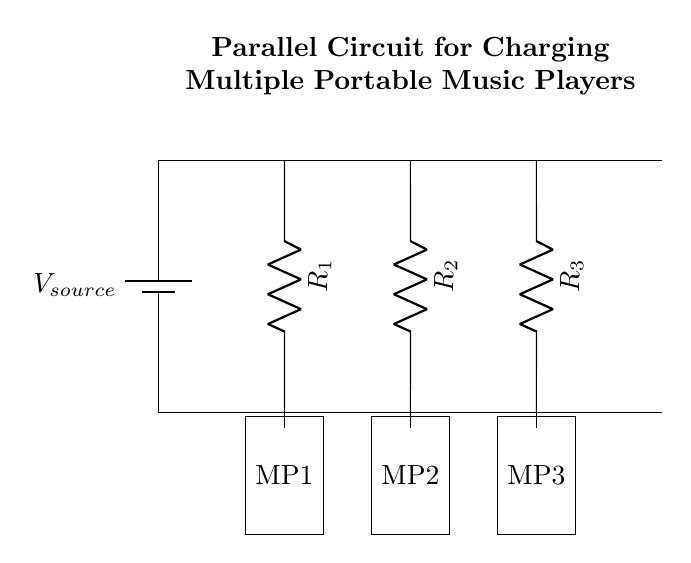What is the type of circuit shown? The circuit is a parallel circuit, as indicated by the arrangement of components where each resistor is connected to the same two nodes, allowing multiple paths for current to flow.
Answer: Parallel circuit How many music players are in the circuit? There are three music players shown in the circuit diagram, designated as MP1, MP2, and MP3, each connected to its own resistor.
Answer: Three What is the primary function of this circuit? This circuit is designed to charge multiple portable music players simultaneously, allowing each player to receive current independently.
Answer: Charge music players What would happen if one of the resistors failed? If one resistor fails, the remaining resistors would still allow current to flow, and the other music players would continue to charge, highlighting the reliability of parallel circuits.
Answer: Others continue charging What is the role of the voltage source in this circuit? The voltage source provides the necessary electrical potential to drive the current through the circuit, allowing energy to be delivered to all connected players.
Answer: Provides voltage What is the effect of adding more music players to the circuit? Adding more music players would create additional parallel branches, which would maintain the same voltage across all players while decreasing overall resistance in the circuit.
Answer: Decreases resistance How do currents compare across the music players in this circuit? The current through each music player can vary according to the resistance of each branch, but they all receive the same voltage from the source, demonstrating characteristic parallel circuit behavior.
Answer: Varies by resistance 